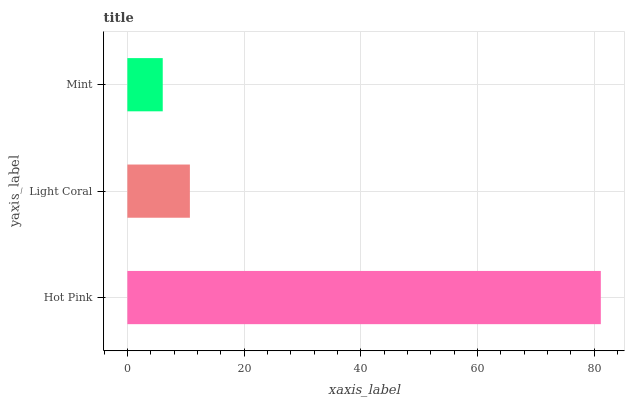Is Mint the minimum?
Answer yes or no. Yes. Is Hot Pink the maximum?
Answer yes or no. Yes. Is Light Coral the minimum?
Answer yes or no. No. Is Light Coral the maximum?
Answer yes or no. No. Is Hot Pink greater than Light Coral?
Answer yes or no. Yes. Is Light Coral less than Hot Pink?
Answer yes or no. Yes. Is Light Coral greater than Hot Pink?
Answer yes or no. No. Is Hot Pink less than Light Coral?
Answer yes or no. No. Is Light Coral the high median?
Answer yes or no. Yes. Is Light Coral the low median?
Answer yes or no. Yes. Is Mint the high median?
Answer yes or no. No. Is Hot Pink the low median?
Answer yes or no. No. 